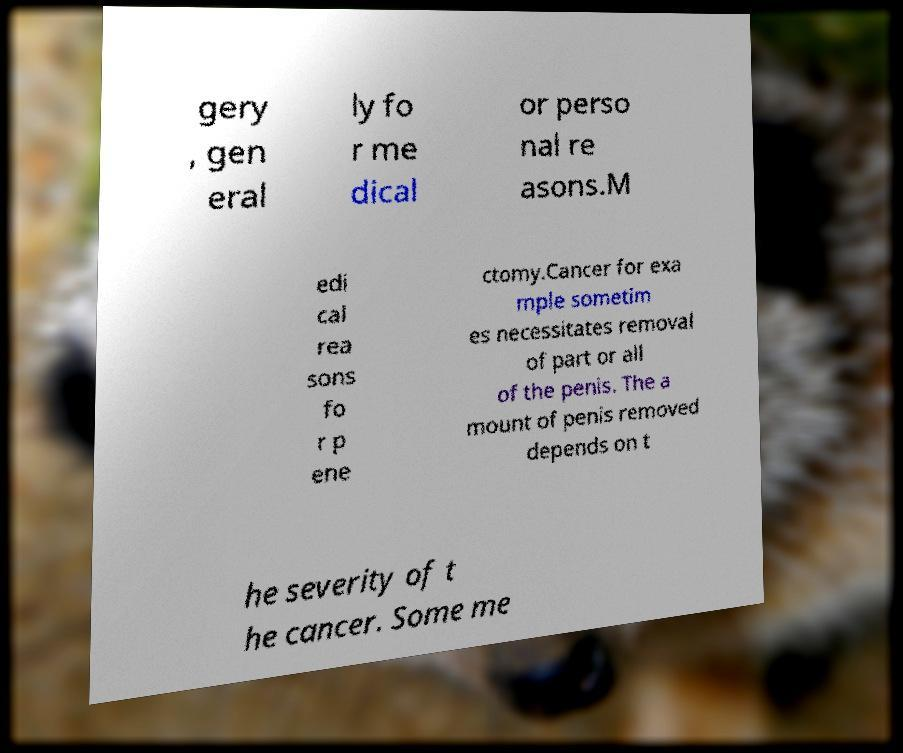Please identify and transcribe the text found in this image. gery , gen eral ly fo r me dical or perso nal re asons.M edi cal rea sons fo r p ene ctomy.Cancer for exa mple sometim es necessitates removal of part or all of the penis. The a mount of penis removed depends on t he severity of t he cancer. Some me 